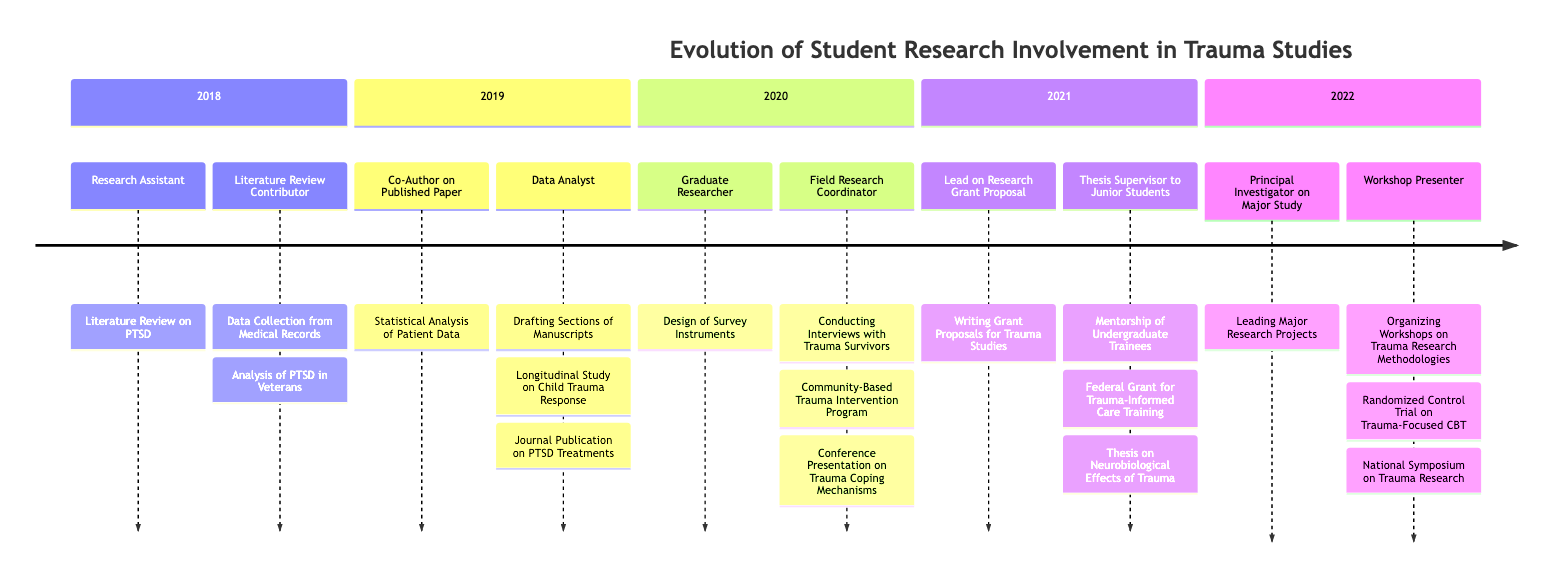What roles were assigned in 2019? In 2019, the roles assigned were "Co-Author on Published Paper" and "Data Analyst". By checking the timeline for the year 2019, we can directly see these roles listed.
Answer: Co-Author on Published Paper, Data Analyst How many key projects were undertaken in 2020? In 2020, there were two key projects mentioned: "Community-Based Trauma Intervention Program" and "Conference Presentation on Trauma Coping Mechanisms". Counting these projects gives us the total.
Answer: 2 What was a primary responsibility of students in 2021? One of the primary responsibilities in 2021 was "Writing Grant Proposals for Trauma Studies". This is listed under the role of "Lead on Research Grant Proposal".
Answer: Writing Grant Proposals for Trauma Studies Which year involved organizing workshops on trauma research methodologies? Organizing workshops on trauma research methodologies was a responsibility in 2022. We can find this by looking at the responsibilities listed for that year.
Answer: 2022 What was the main focus of the key project in 2021? The main focus of a key project in 2021 was the "Federal Grant for Trauma-Informed Care Training". This is explicitly mentioned as one of the key projects for that year.
Answer: Federal Grant for Trauma-Informed Care Training What were the roles in the first year, 2018? The roles in 2018 included "Research Assistant" and "Literature Review Contributor". These are listed under that year's section in the timeline.
Answer: Research Assistant, Literature Review Contributor How many roles were listed in 2020? In 2020, there were two roles listed: "Graduate Researcher" and "Field Research Coordinator". This can be confirmed by counting the roles for that year.
Answer: 2 What was a key project for students in 2019? A key project for 2019 was the "Longitudinal Study on Child Trauma Response". This is directly listed under that year in the key projects section.
Answer: Longitudinal Study on Child Trauma Response Which role involved mentorship in 2021? The role that involved mentorship in 2021 was "Thesis Supervisor to Junior Students". This is found in the roles section for that year.
Answer: Thesis Supervisor to Junior Students 